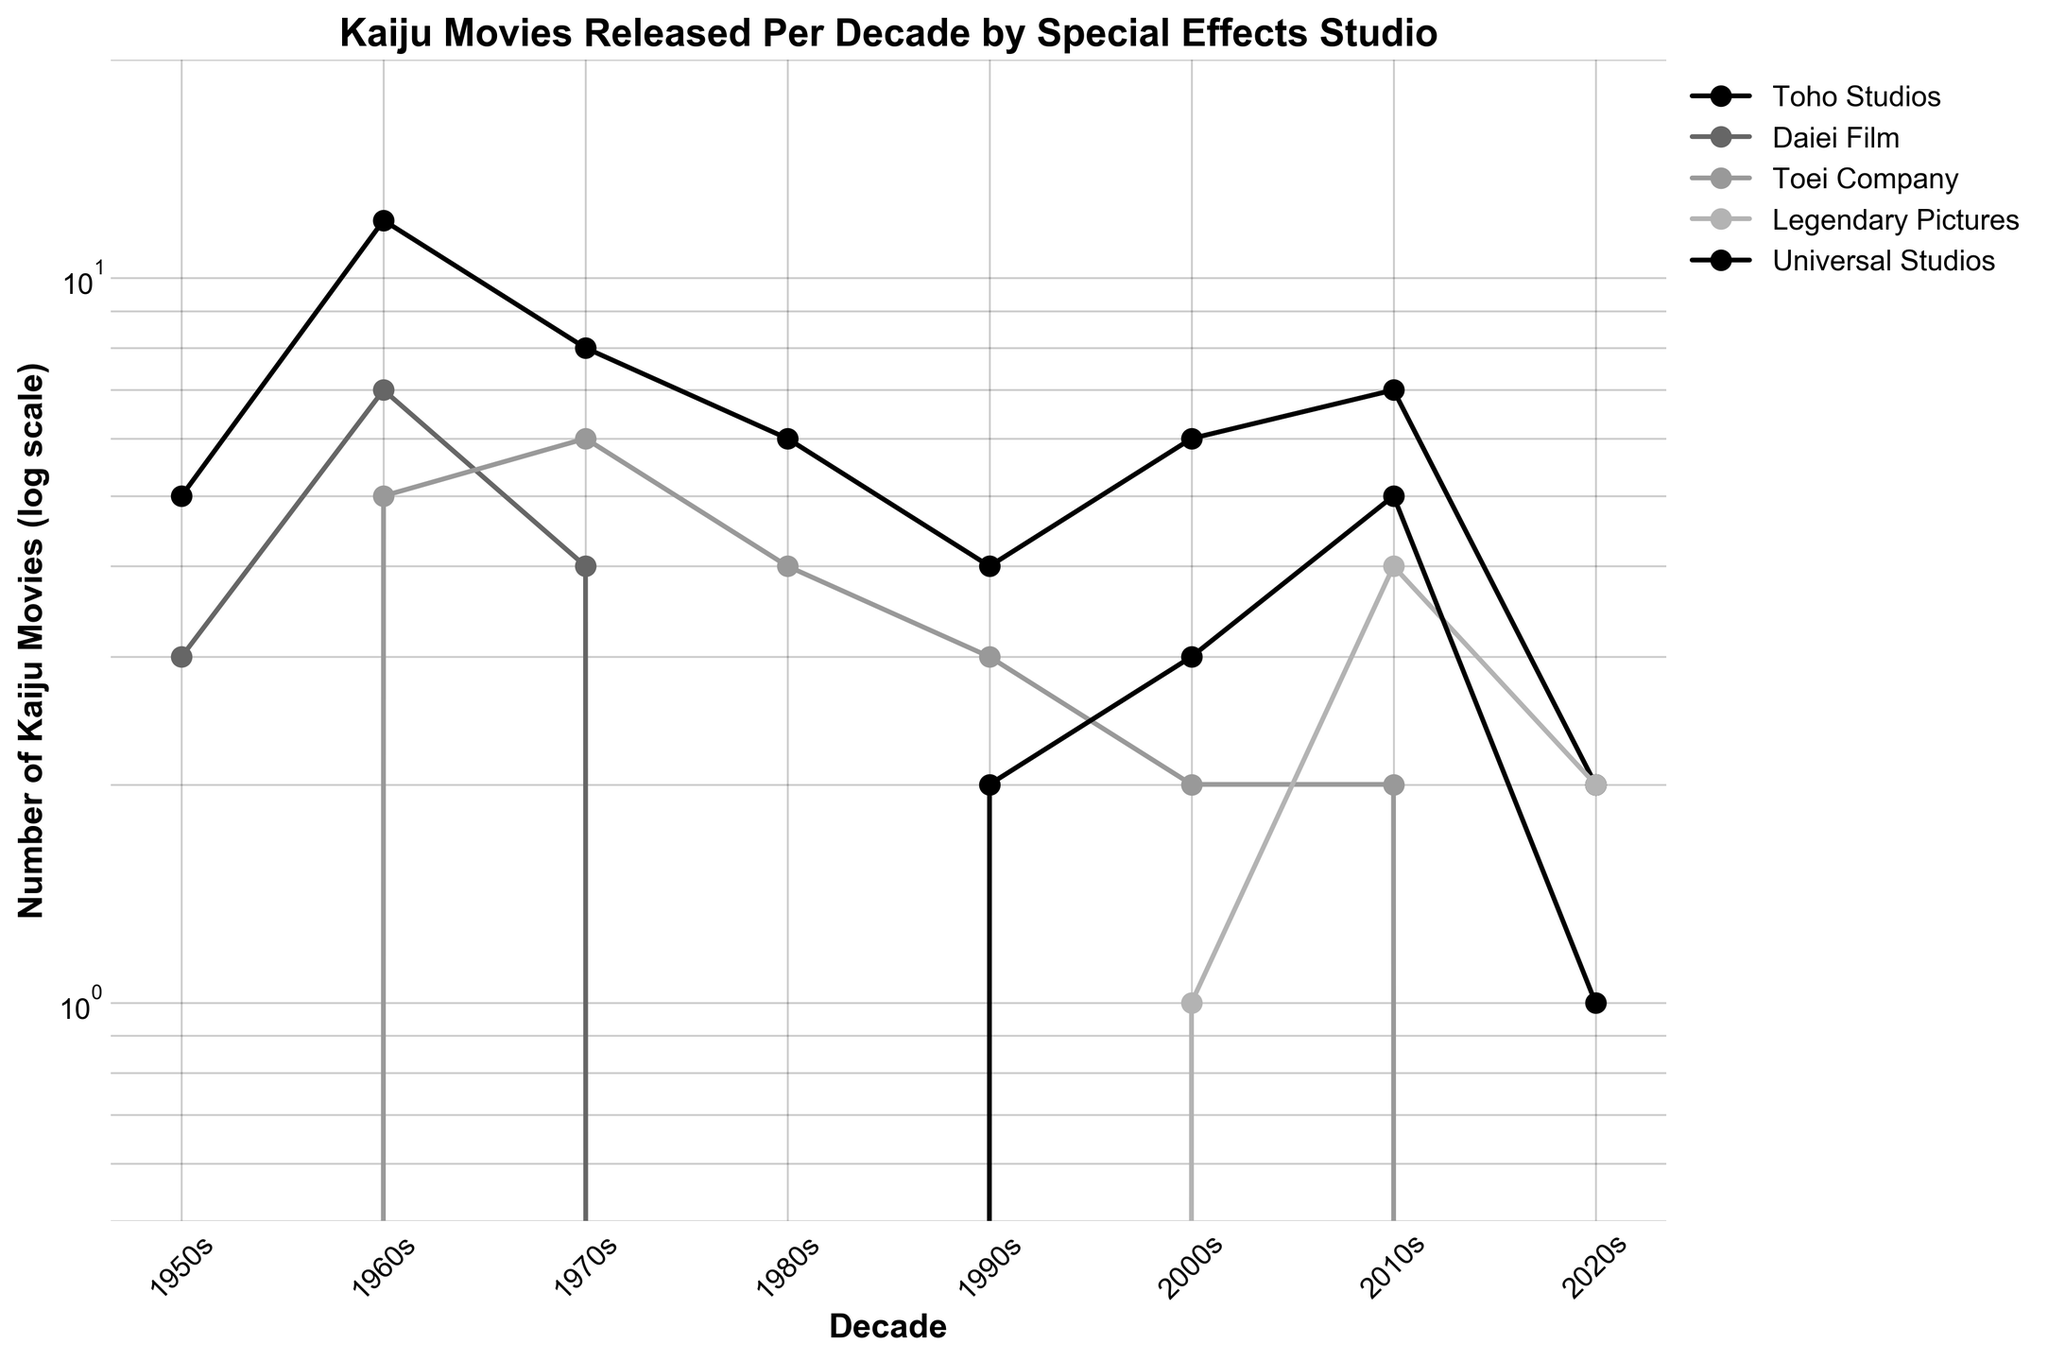Which studio has the highest number of kaiju movies in the 1960s? The line plot indicates that Toho Studios peaked in the 1960s with 12 kaiju movies, the highest for that decade.
Answer: Toho Studios How many kaiju movies did Daiei Film release in the 1980s? The line plot shows the number of movies released by Daiei Film in each decade. For the 1980s, the count is zero.
Answer: 0 Which decade saw the emergence of kaiju movies by Legendary Pictures? Legendary Pictures is marked in the plot with an increase in movie numbers starting from the 2000s.
Answer: 2000s How does the number of kaiju movies released by Toho Studios in the 1970s compare to those in the 1980s? The graph shows that Toho Studios released 8 movies in the 1970s and 6 movies in the 1980s. The difference is 8 - 6 = 2.
Answer: 2 fewer Which studio showed a consistent increase in the number of kaiju movies from the 2000s to the 2010s? The plot indicates that Legendary Pictures increased from 1 movie in the 2000s to 4 in the 2010s.
Answer: Legendary Pictures How many total kaiju movies did Universal Studios release between the 1990s and the 2020s? The graph indicates Universal Studios released 2 in the 1990s, 3 in the 2000s, 5 in the 2010s, and 1 in the 2020s. The total is 2 + 3 + 5 + 1 = 11.
Answer: 11 What is the overall trend observed for Toei Company from the 1960s to the 2020s? The line plot shows that Toei Company had a peak in the 1960s with 5 movies, followed by gradual decline to 0 in the subsequent decades.
Answer: Decreasing Which studio had the sharpest decline in the number of kaiju movies between any two consecutive decades? Looking at the plot, Toei Company had the sharpest decline from the 1970s (6 movies) to the 1980s (4 movies), a decrease of 2.
Answer: Toei Company What can be inferred about Daiei Film's activity in the kaiju genre after the 1960s? From the line plot, it is evident that Daiei Film had some activity in the 1960s but showed decline to zero movies in subsequent decades.
Answer: Declined to zero 